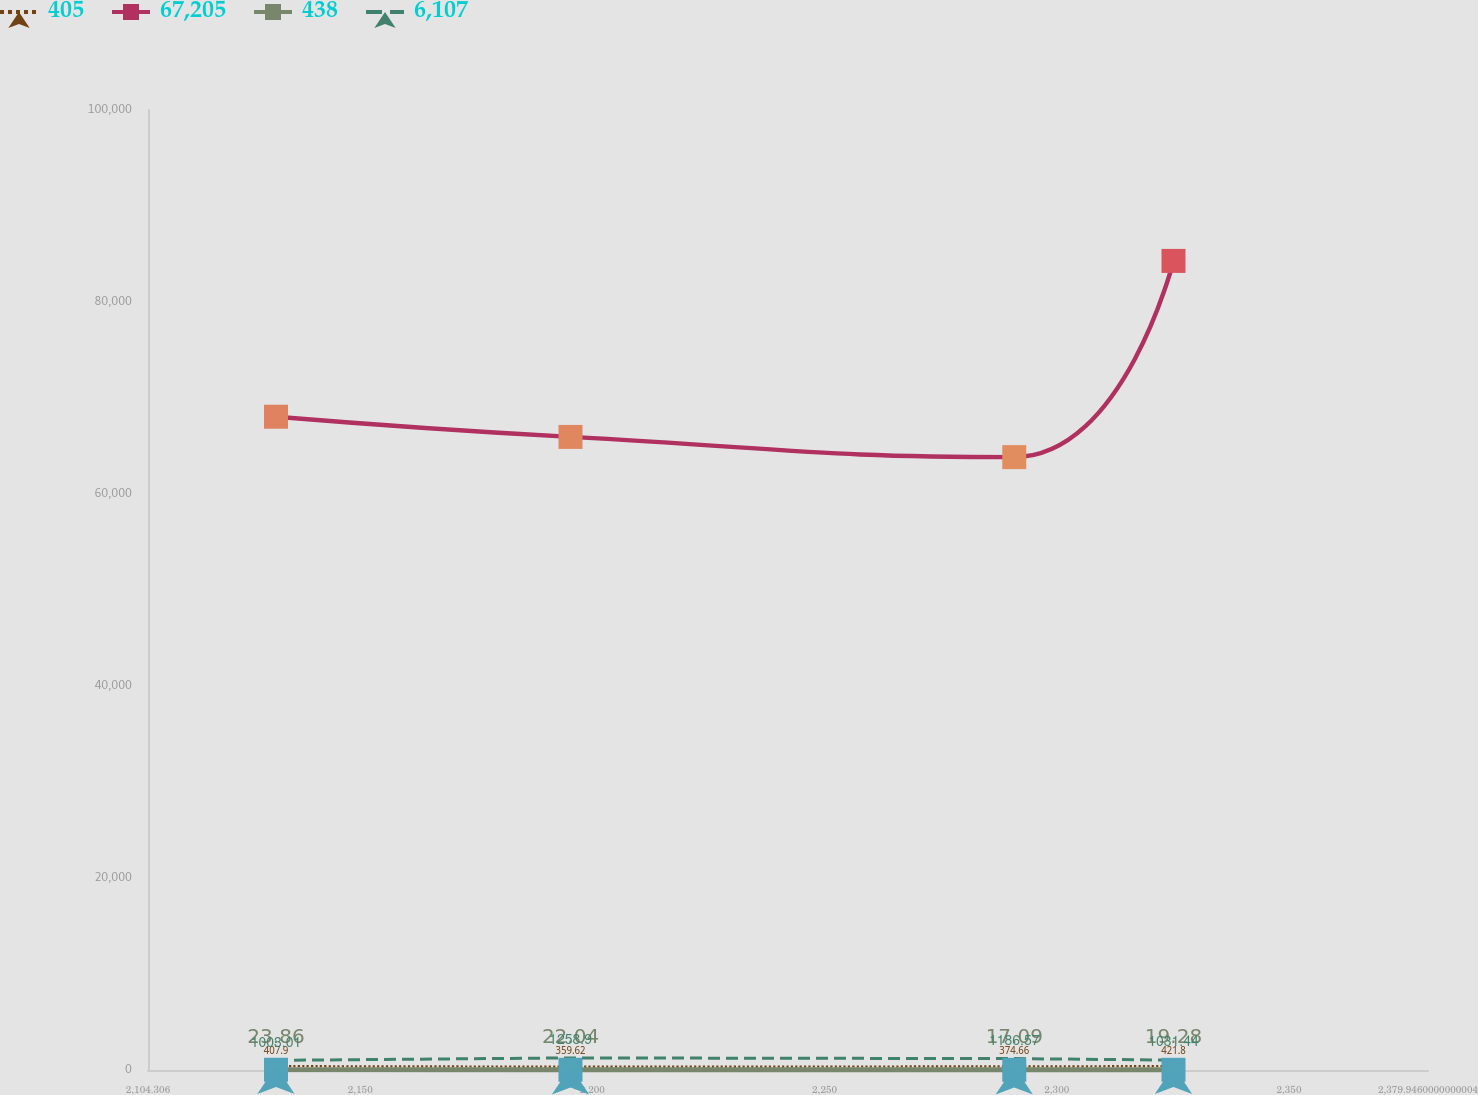Convert chart. <chart><loc_0><loc_0><loc_500><loc_500><line_chart><ecel><fcel>405<fcel>67,205<fcel>438<fcel>6,107<nl><fcel>2131.87<fcel>407.9<fcel>68049.2<fcel>23.86<fcel>1003.01<nl><fcel>2195.29<fcel>359.62<fcel>65945.6<fcel>22.04<fcel>1258.9<nl><fcel>2290.85<fcel>374.66<fcel>63842.1<fcel>17.09<fcel>1186.57<nl><fcel>2325.14<fcel>421.8<fcel>84280.2<fcel>19.28<fcel>1031.44<nl><fcel>2407.51<fcel>498.65<fcel>86383.8<fcel>22.72<fcel>974.58<nl></chart> 